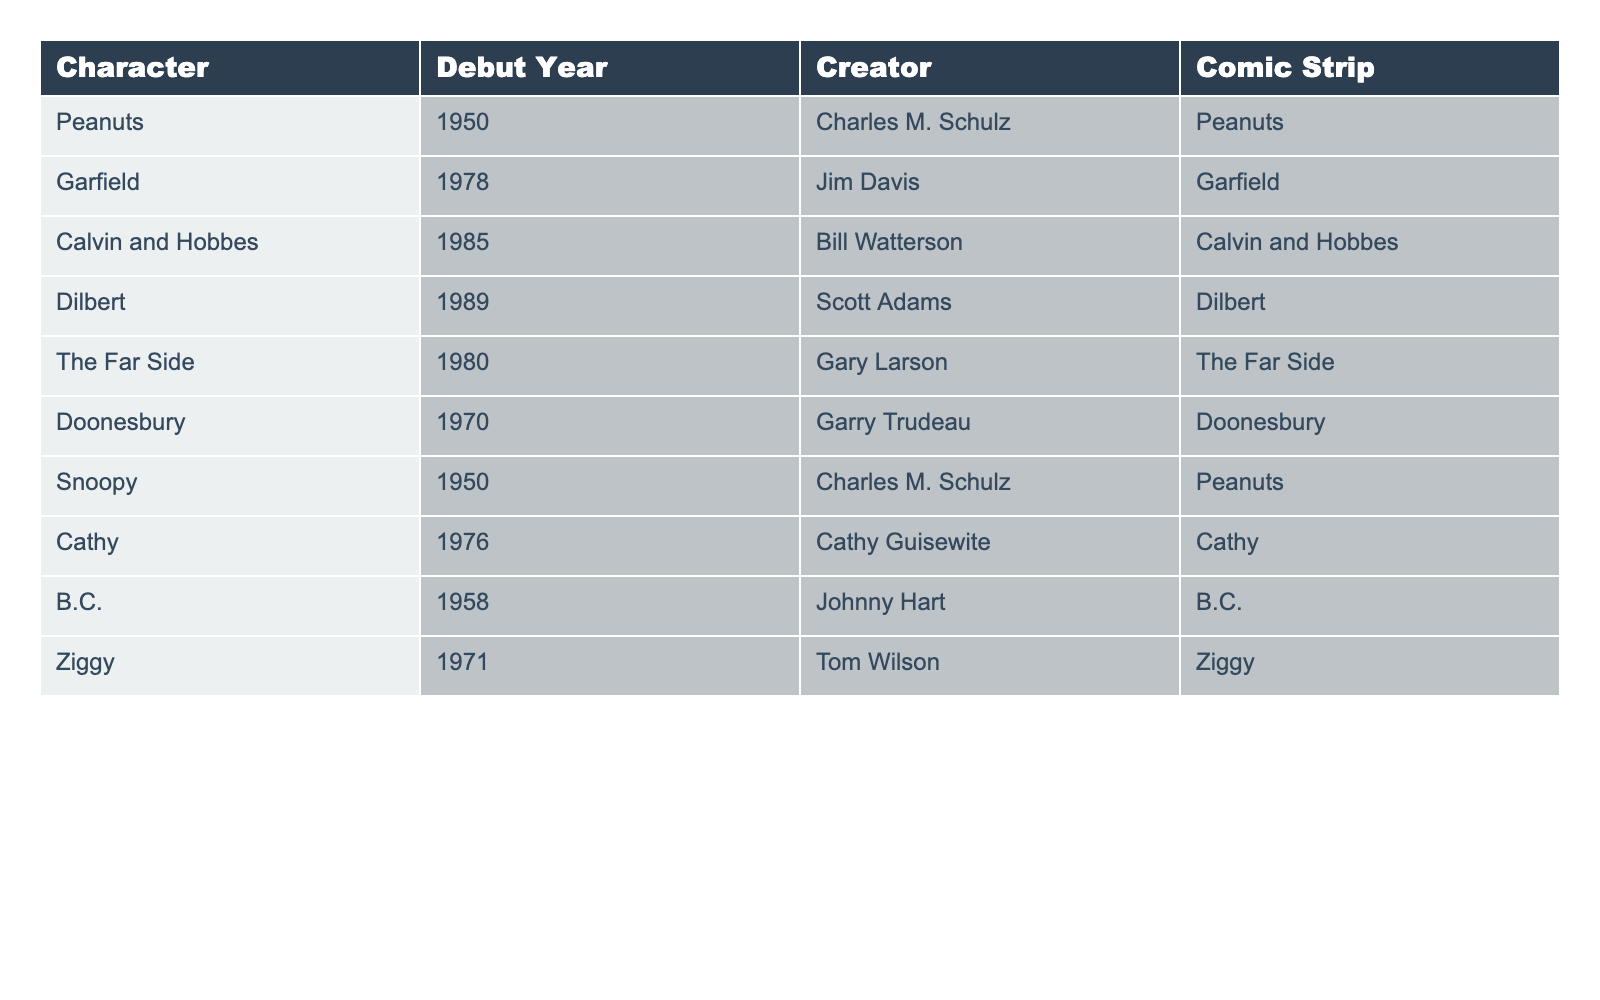What year did Garfield debut? Garfield debuted in 1978, which can be found in the column corresponding to the character Garfield.
Answer: 1978 Who created Peanuts? The creator of Peanuts is Charles M. Schulz, as listed in the creator column for Peanuts.
Answer: Charles M. Schulz Which character debuted first, Cathy or Dilbert? Cathy debuted in 1976 and Dilbert in 1989. Since 1976 is earlier than 1989, Cathy debuted first.
Answer: Cathy Is there a character that debuted in the same year as Snoopy? Snoopy debuted in 1950, and the only other character that debuted in that same year is Peanuts, which features Snoopy as a character.
Answer: Yes Calculate the average debut year of the comic strips listed. To find the average, add all the debut years (1950 + 1978 + 1985 + 1989 + 1980 + 1970 + 1950 + 1976 + 1958 + 1971 = 1977.7) and divide by 10. The sum is 19777 divided by 10 equals approximately 1977.7.
Answer: 1977.7 How many characters debuted before 1980? The years before 1980 are 1950 (2), 1958 (1), 1970 (1), 1971 (1), and 1976 (1), making a total of 6 characters that debuted before 1980.
Answer: 6 Was The Far Side created by the same person as Calvin and Hobbes? No, The Far Side was created by Gary Larson, while Calvin and Hobbes was created by Bill Watterson; hence they have different creators.
Answer: No What is the difference in years between the debut of B.C. and Ziggy? B.C. debuted in 1958, and Ziggy in 1971. The difference is calculated as (1971 - 1958 = 13 years).
Answer: 13 years Which character has the latest debut year? From the table, Dilbert debuted in 1989, which is the latest year compared to the other characters listed.
Answer: Dilbert Is there any character that debuted in the same decade as both Garfield and The Far Side? Garfield debuted in 1978 and The Far Side in 1980, both in the 1970s. Hence, characters that debuted in that decade are valid. Since Doonesbury (1970) and Ziggy (1971) also debuted in the 1970s alongside Garfield and The Far Side, the answer is yes.
Answer: Yes 